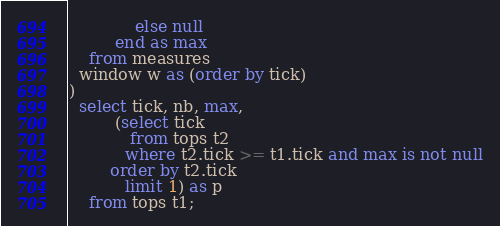Convert code to text. <code><loc_0><loc_0><loc_500><loc_500><_SQL_>             else null
         end as max
    from measures
  window w as (order by tick)
)
  select tick, nb, max,
         (select tick
            from tops t2
           where t2.tick >= t1.tick and max is not null
        order by t2.tick
           limit 1) as p
    from tops t1;
</code> 